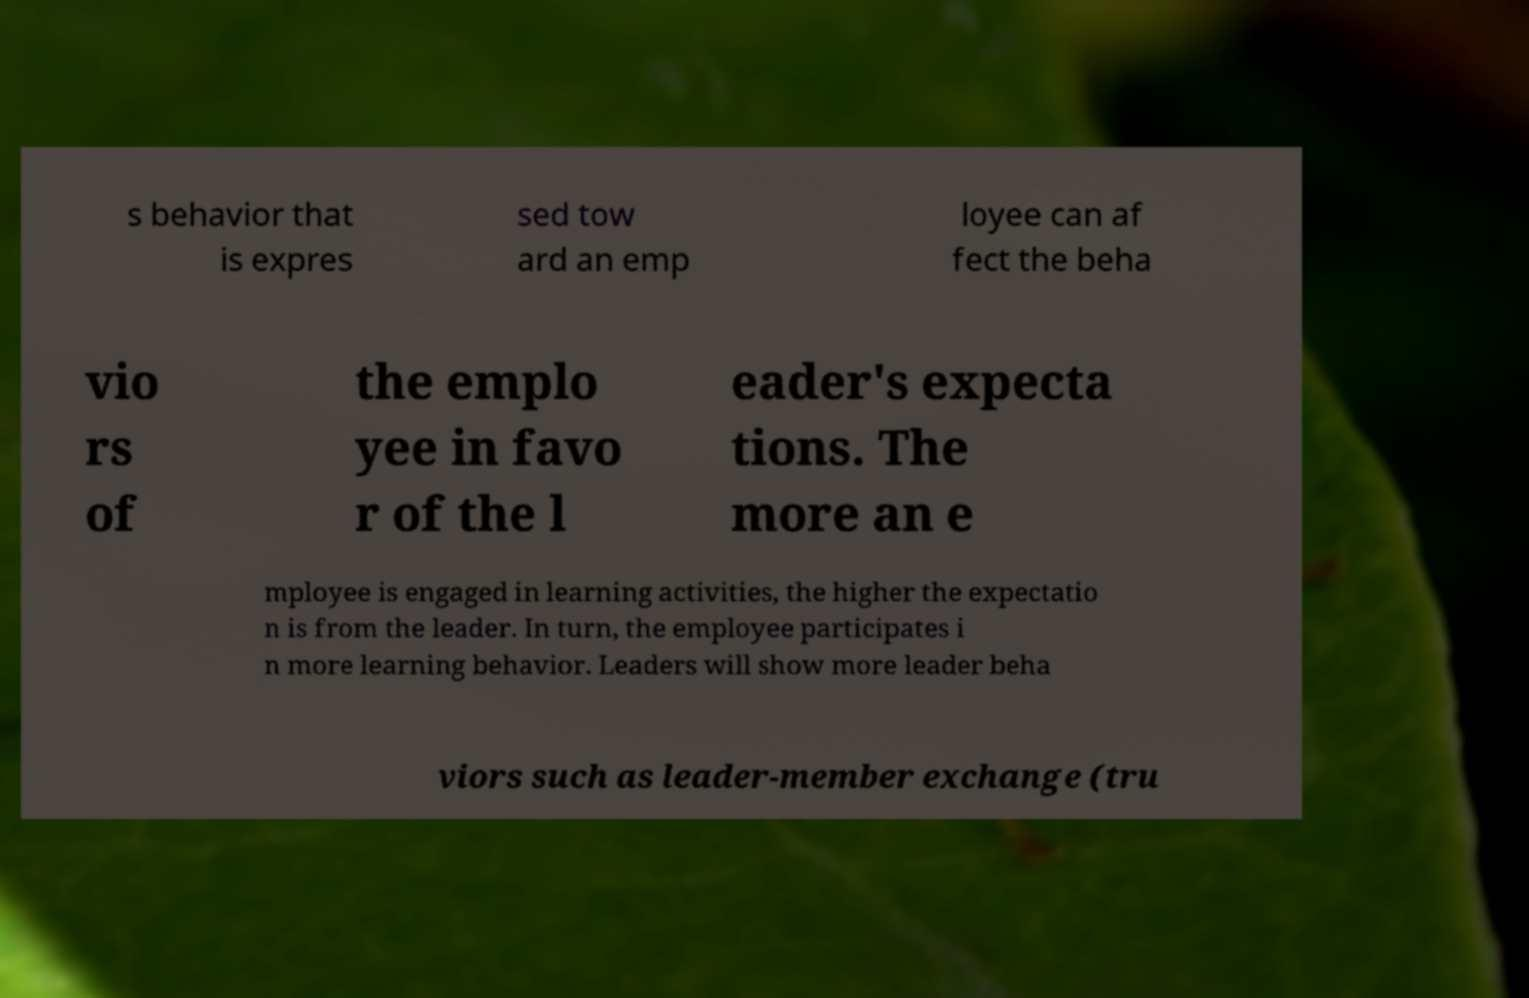For documentation purposes, I need the text within this image transcribed. Could you provide that? s behavior that is expres sed tow ard an emp loyee can af fect the beha vio rs of the emplo yee in favo r of the l eader's expecta tions. The more an e mployee is engaged in learning activities, the higher the expectatio n is from the leader. In turn, the employee participates i n more learning behavior. Leaders will show more leader beha viors such as leader-member exchange (tru 